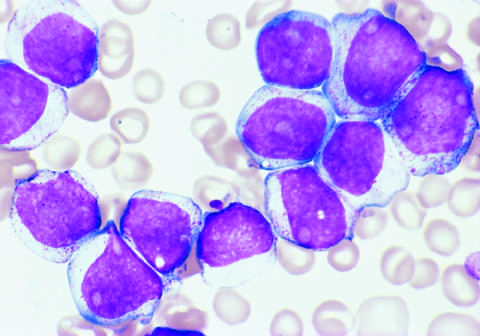re the tumor cells positive for the stem cell marker cd34 and the myeloid lineage specific markers cd33 and cd15 subset?
Answer the question using a single word or phrase. Yes 